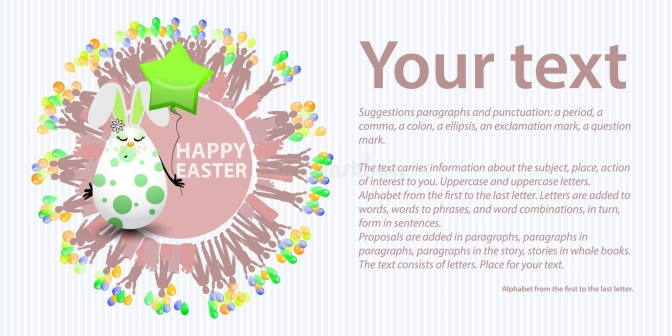Can you imagine a short story that involves the bunny in this image? Once upon a time, in a vibrant meadow, lived a whimsical Easter bunny named Pip. Pip had a magical touch that could bring colors to life. One fine Easter morning, Pip decided to throw a grand celebration for all his woodland friends. Holding a star-shaped balloon, Pip invited everyone with a radiant smile. The meadow transformed into a canvas of colors, as Pip's touch brought forth a burst of confetti in the air. Right at the center of it all, was a circular sign saying 'HAPPY EASTER,' welcoming everyone to the joyous festival. The lively scene was punctuated by a customizable banner where the guests could write their Easter wishes. This joyous celebration marked the beginning of an unforgettable Easter. That's a lovely story! What other activities do you think Pip and his friends might enjoy during the Easter celebration? Pip and his friends could engage in various delightful activities. They might organize an Easter egg hunt, where colorful eggs are hidden around the meadow for everyone to find. There could be a crafts station where the animals decorate their own Easter eggs with paint and glitter. A playful game of 'Pin the Tail on the Bunny' might ensue, bringing laughter and joy to all. As the sun begins to set, Pip might light up the meadow with lanterns, and everyone could gather around a bonfire to share stories and enjoy some freshly baked carrot cake. The celebration would end with a dance under the stars, with Pip's magical touch adding a sparkle to the night. 